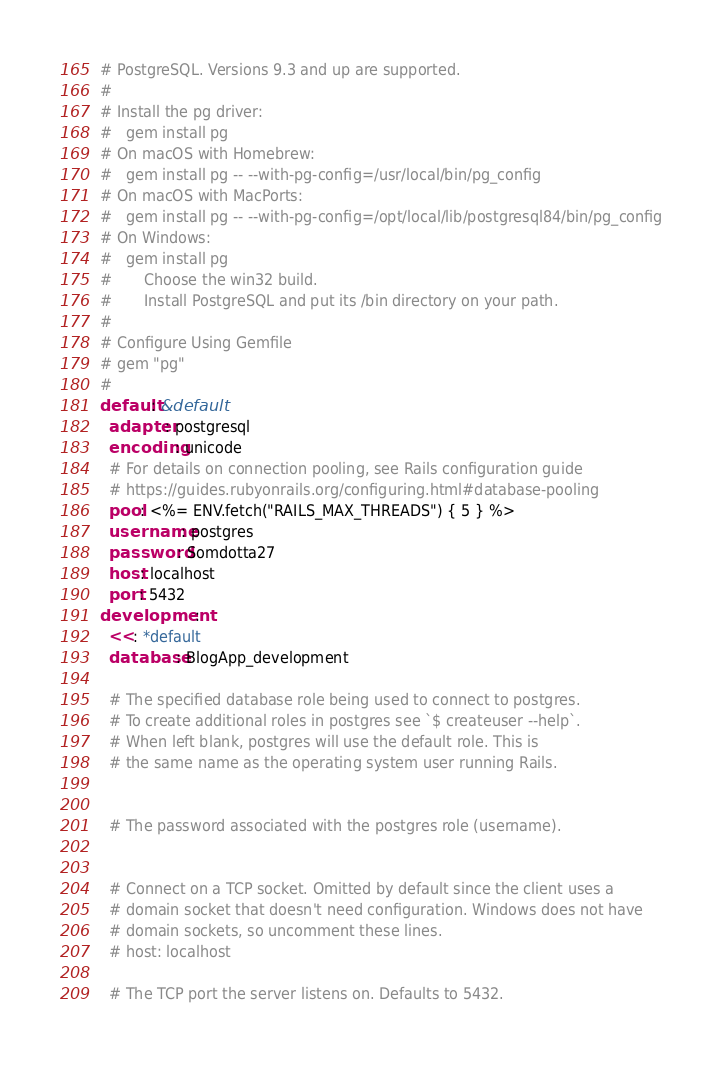<code> <loc_0><loc_0><loc_500><loc_500><_YAML_># PostgreSQL. Versions 9.3 and up are supported.
#
# Install the pg driver:
#   gem install pg
# On macOS with Homebrew:
#   gem install pg -- --with-pg-config=/usr/local/bin/pg_config
# On macOS with MacPorts:
#   gem install pg -- --with-pg-config=/opt/local/lib/postgresql84/bin/pg_config
# On Windows:
#   gem install pg
#       Choose the win32 build.
#       Install PostgreSQL and put its /bin directory on your path.
#
# Configure Using Gemfile
# gem "pg"
#
default: &default
  adapter: postgresql
  encoding: unicode
  # For details on connection pooling, see Rails configuration guide
  # https://guides.rubyonrails.org/configuring.html#database-pooling
  pool: <%= ENV.fetch("RAILS_MAX_THREADS") { 5 } %>
  username: postgres
  password: Somdotta27
  host: localhost
  port: 5432
development:
  <<: *default
  database: BlogApp_development

  # The specified database role being used to connect to postgres.
  # To create additional roles in postgres see `$ createuser --help`.
  # When left blank, postgres will use the default role. This is
  # the same name as the operating system user running Rails.


  # The password associated with the postgres role (username).
 

  # Connect on a TCP socket. Omitted by default since the client uses a
  # domain socket that doesn't need configuration. Windows does not have
  # domain sockets, so uncomment these lines.
  # host: localhost

  # The TCP port the server listens on. Defaults to 5432.</code> 